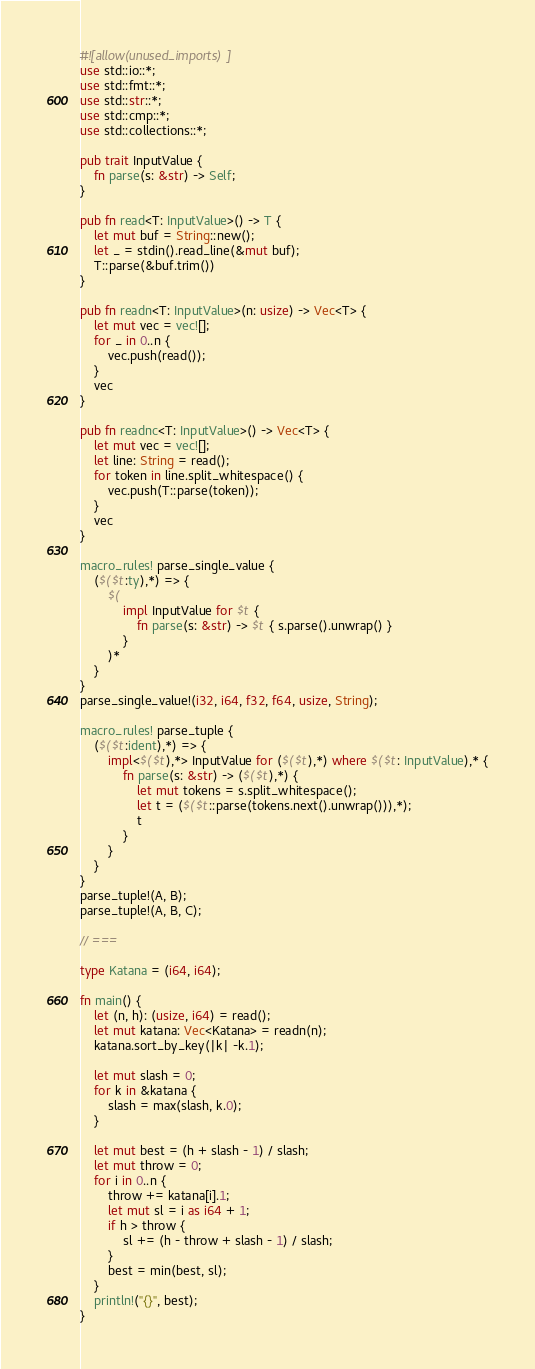Convert code to text. <code><loc_0><loc_0><loc_500><loc_500><_Rust_>#![allow(unused_imports)]
use std::io::*;
use std::fmt::*;
use std::str::*;
use std::cmp::*;
use std::collections::*;

pub trait InputValue {
    fn parse(s: &str) -> Self;
}

pub fn read<T: InputValue>() -> T {
    let mut buf = String::new();
    let _ = stdin().read_line(&mut buf);
    T::parse(&buf.trim())
}

pub fn readn<T: InputValue>(n: usize) -> Vec<T> {
    let mut vec = vec![];
    for _ in 0..n {
        vec.push(read());
    }
    vec
}

pub fn readnc<T: InputValue>() -> Vec<T> {
    let mut vec = vec![];
    let line: String = read();
    for token in line.split_whitespace() {
        vec.push(T::parse(token));
    }
    vec
}

macro_rules! parse_single_value {
    ($($t:ty),*) => {
        $(
            impl InputValue for $t {
                fn parse(s: &str) -> $t { s.parse().unwrap() }
            }
        )*
	}
}
parse_single_value!(i32, i64, f32, f64, usize, String);

macro_rules! parse_tuple {
	($($t:ident),*) => {
		impl<$($t),*> InputValue for ($($t),*) where $($t: InputValue),* {
			fn parse(s: &str) -> ($($t),*) {
				let mut tokens = s.split_whitespace();
				let t = ($($t::parse(tokens.next().unwrap())),*);
				t
			}
		}
	}
}
parse_tuple!(A, B);
parse_tuple!(A, B, C);

// ===

type Katana = (i64, i64);

fn main() {
    let (n, h): (usize, i64) = read();
    let mut katana: Vec<Katana> = readn(n);
    katana.sort_by_key(|k| -k.1);

    let mut slash = 0;
    for k in &katana {
        slash = max(slash, k.0);
    }

    let mut best = (h + slash - 1) / slash;
    let mut throw = 0;
    for i in 0..n {
        throw += katana[i].1;
        let mut sl = i as i64 + 1;
        if h > throw {
            sl += (h - throw + slash - 1) / slash;
        }
        best = min(best, sl);
    }
    println!("{}", best);
}
</code> 